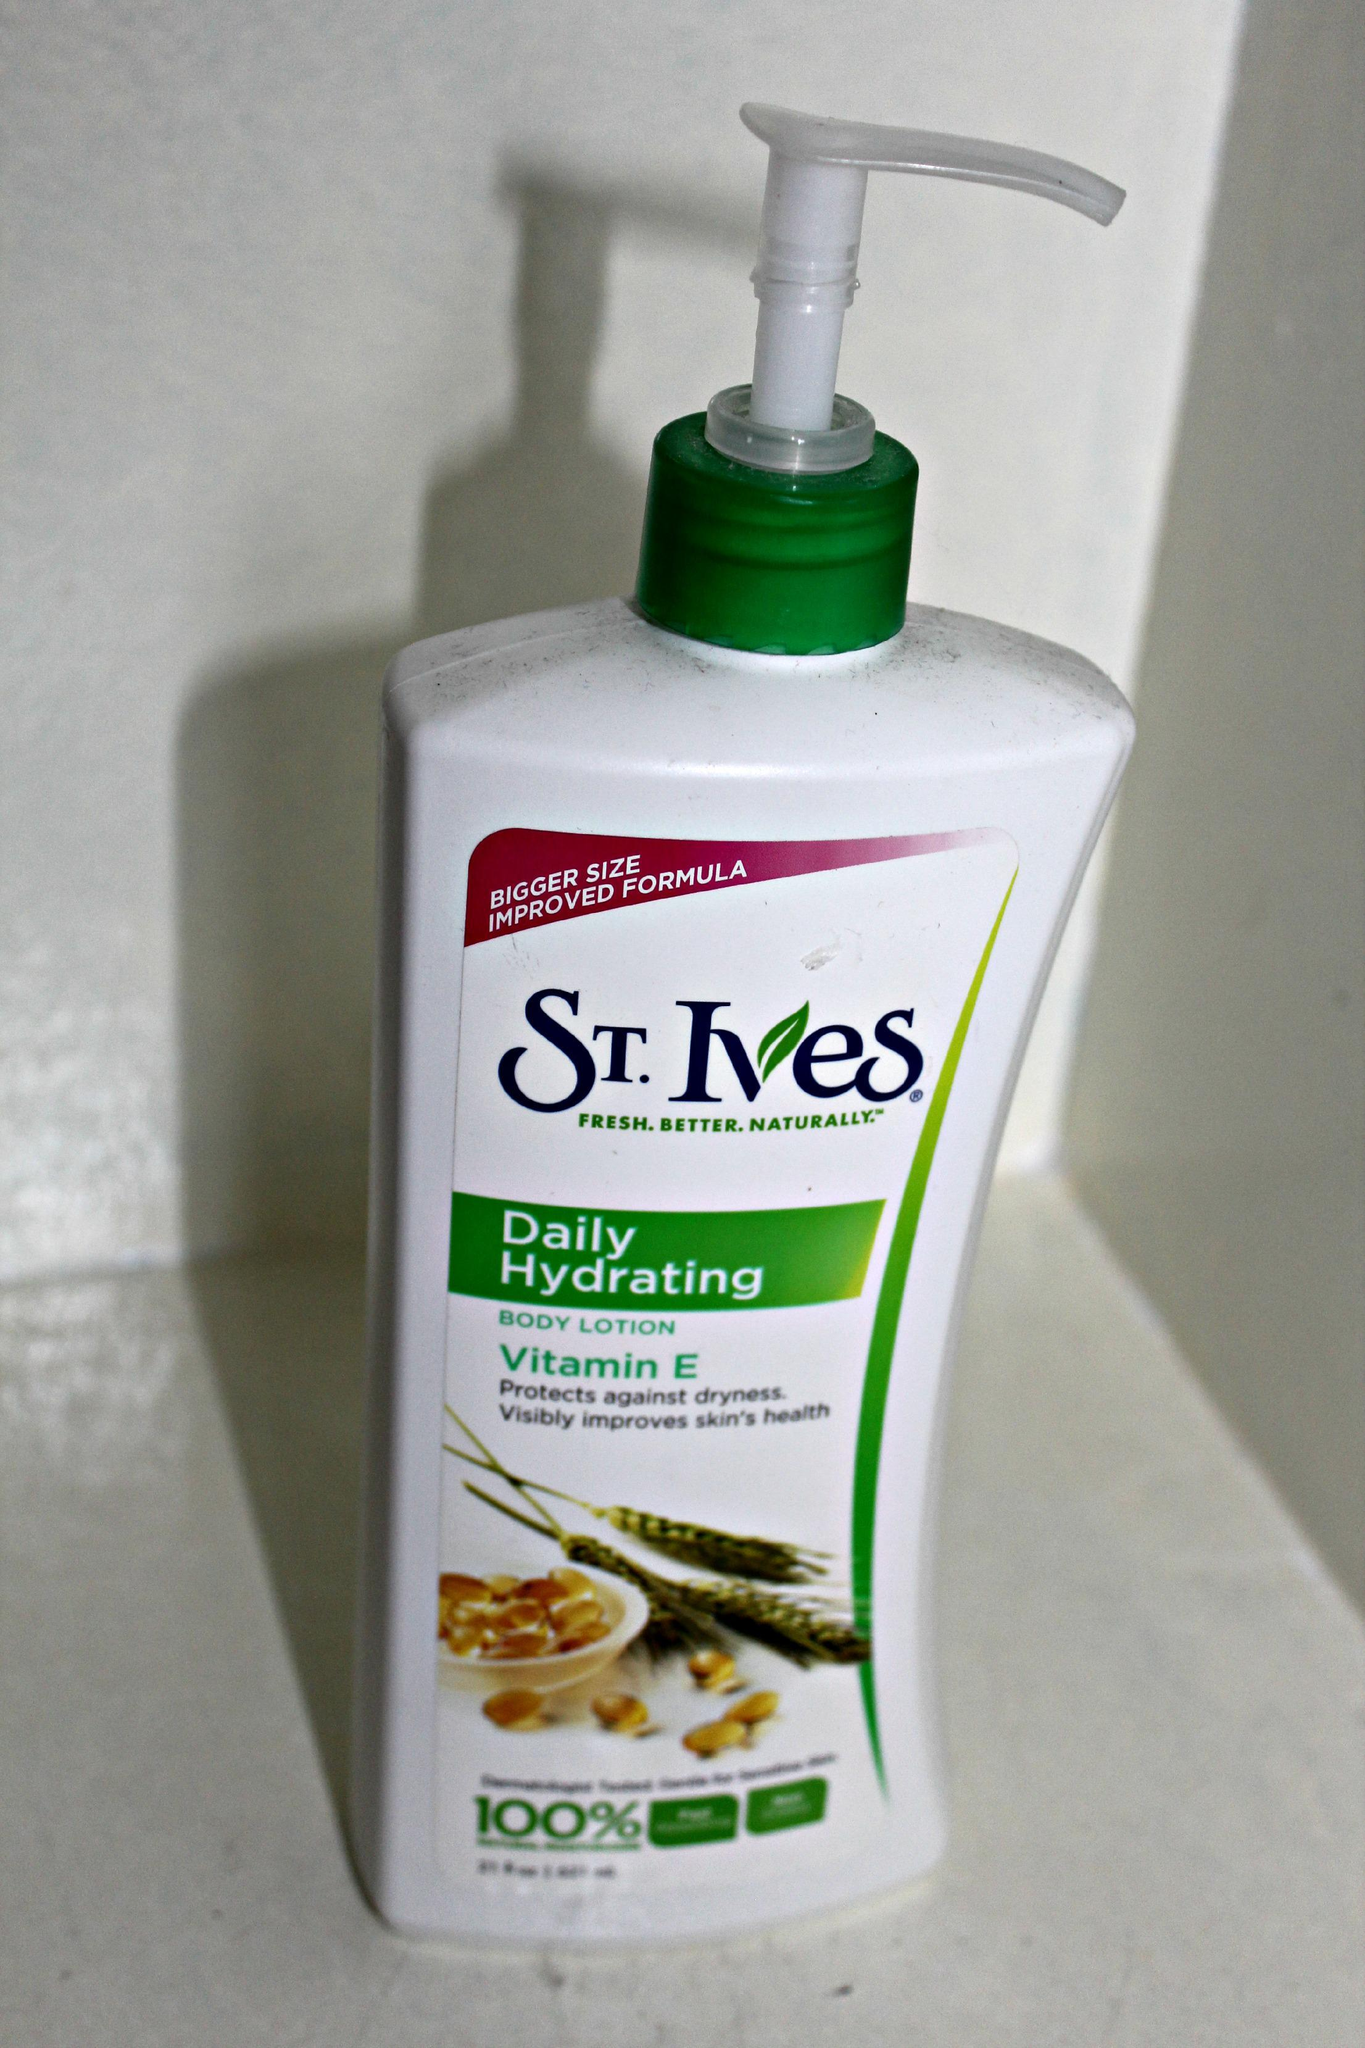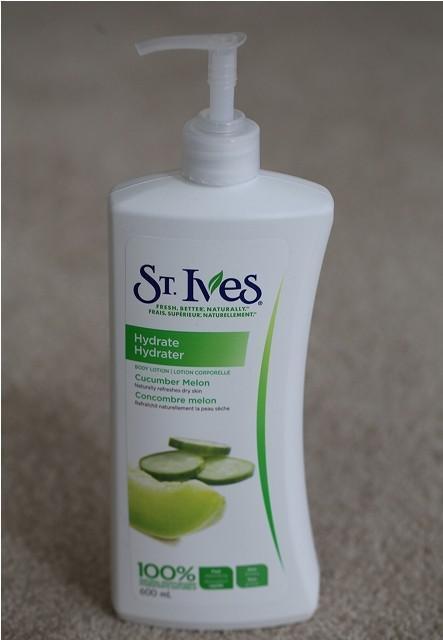The first image is the image on the left, the second image is the image on the right. For the images displayed, is the sentence "One image shows exactly one pump-top product with the nozzle facing right, and the other image shows exactly one pump-top product with the nozzle facing left." factually correct? Answer yes or no. Yes. The first image is the image on the left, the second image is the image on the right. Analyze the images presented: Is the assertion "Each image has one bottle of lotion with a pump top, both the same brand, but with different labels." valid? Answer yes or no. Yes. 